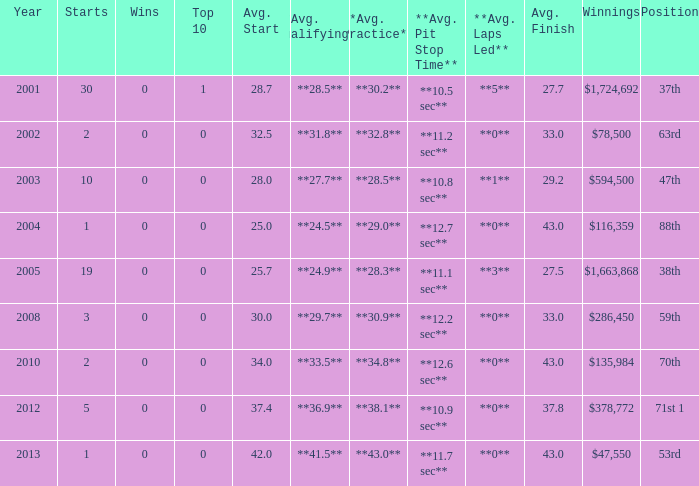How many wins for average start less than 25? 0.0. 